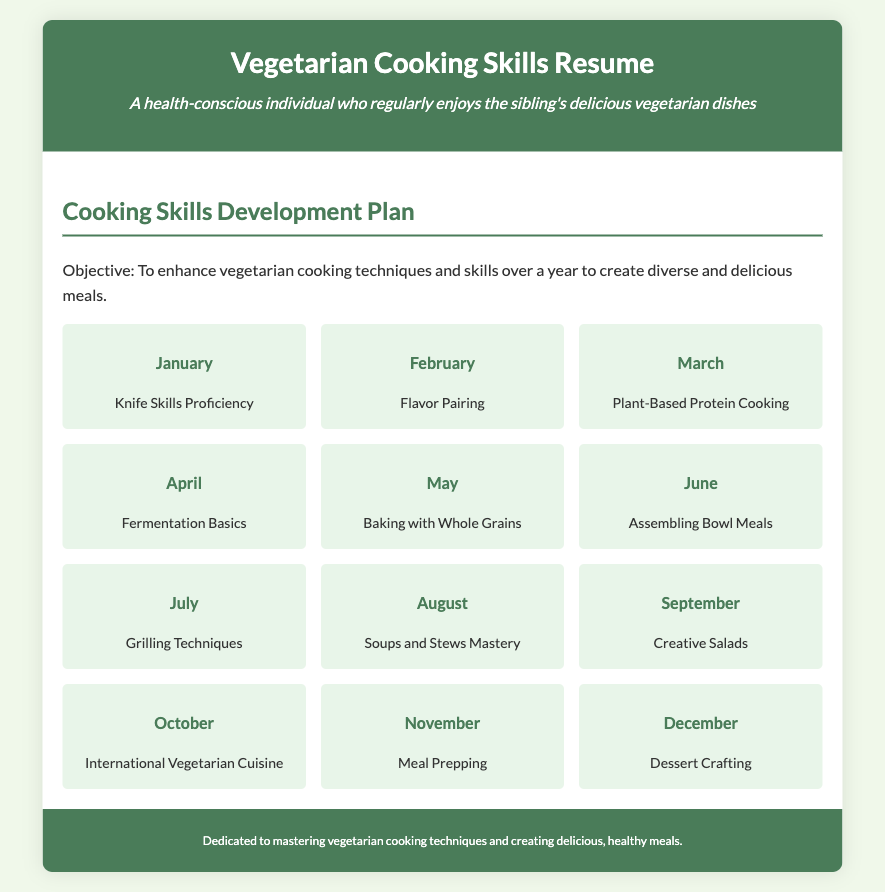What is the first skill to master? The first skill to master is listed as "Knife Skills Proficiency" for January.
Answer: Knife Skills Proficiency What month is dedicated to Flavor Pairing? Flavor Pairing is scheduled for February, which is the second month.
Answer: February How many cooking skills are outlined in the plan? There are twelve months, each with a skill outlined, making a total of twelve skills.
Answer: Twelve What skill is focused on in April? The skill for April is "Fermentation Basics."
Answer: Fermentation Basics Which month emphasizes international cuisine? "International Vegetarian Cuisine" is the skill for October.
Answer: October What cooking technique is scheduled for July? The skill for July is focused on "Grilling Techniques."
Answer: Grilling Techniques What is the objective of the Cooking Skills Development Plan? The objective is to enhance vegetarian cooking techniques and skills over a year.
Answer: Enhance vegetarian cooking techniques What skill involves creating hearty dishes in August? The skill for August is "Soups and Stews Mastery."
Answer: Soups and Stews Mastery Which skill is dedicated to dessert creation? "Dessert Crafting" is the skill highlighted for December.
Answer: Dessert Crafting 